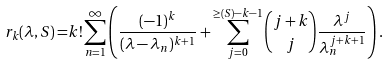Convert formula to latex. <formula><loc_0><loc_0><loc_500><loc_500>r _ { k } ( \lambda , S ) = & k ! \sum _ { n = 1 } ^ { \infty } \left ( \frac { ( - 1 ) ^ { k } } { ( \lambda - \lambda _ { n } ) ^ { k + 1 } } + \sum _ { j = 0 } ^ { \geq ( S ) - k - 1 } \binom { j + k } { j } \frac { \lambda ^ { j } } { \lambda ^ { j + k + 1 } _ { n } } \right ) .</formula> 